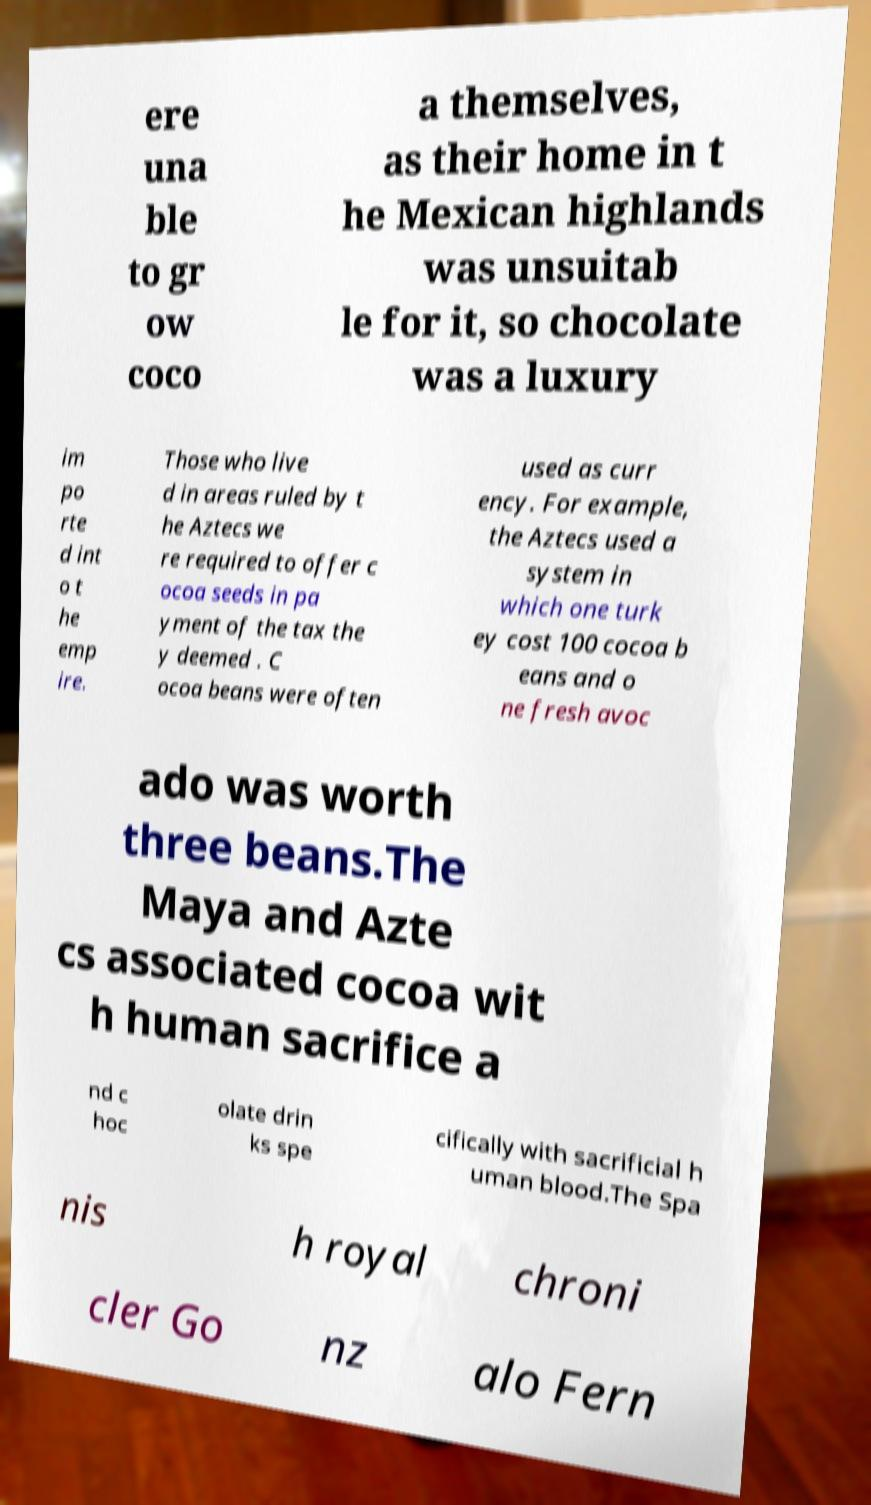Please identify and transcribe the text found in this image. ere una ble to gr ow coco a themselves, as their home in t he Mexican highlands was unsuitab le for it, so chocolate was a luxury im po rte d int o t he emp ire. Those who live d in areas ruled by t he Aztecs we re required to offer c ocoa seeds in pa yment of the tax the y deemed . C ocoa beans were often used as curr ency. For example, the Aztecs used a system in which one turk ey cost 100 cocoa b eans and o ne fresh avoc ado was worth three beans.The Maya and Azte cs associated cocoa wit h human sacrifice a nd c hoc olate drin ks spe cifically with sacrificial h uman blood.The Spa nis h royal chroni cler Go nz alo Fern 